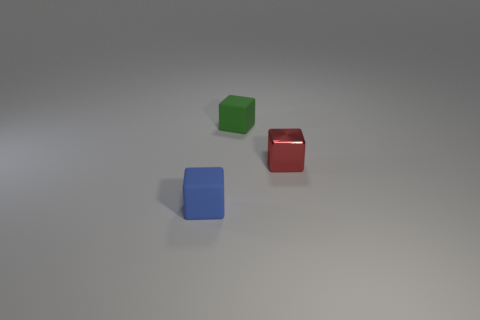There is a object in front of the thing that is to the right of the matte block on the right side of the blue rubber object; what is its shape?
Keep it short and to the point. Cube. The shiny thing that is the same shape as the blue matte object is what color?
Make the answer very short. Red. What size is the thing that is both right of the small blue object and on the left side of the red shiny object?
Give a very brief answer. Small. There is a matte cube behind the small thing to the right of the small green block; how many blue objects are behind it?
Your answer should be very brief. 0. How many small things are either green shiny balls or green matte cubes?
Give a very brief answer. 1. Is the tiny blue cube that is in front of the green cube made of the same material as the green object?
Give a very brief answer. Yes. What material is the small blue cube that is in front of the thing that is right of the rubber object that is right of the small blue object?
Your answer should be compact. Rubber. Is there anything else that has the same size as the red thing?
Offer a very short reply. Yes. How many rubber objects are either large brown spheres or small red objects?
Give a very brief answer. 0. Are there any red objects?
Make the answer very short. Yes. 